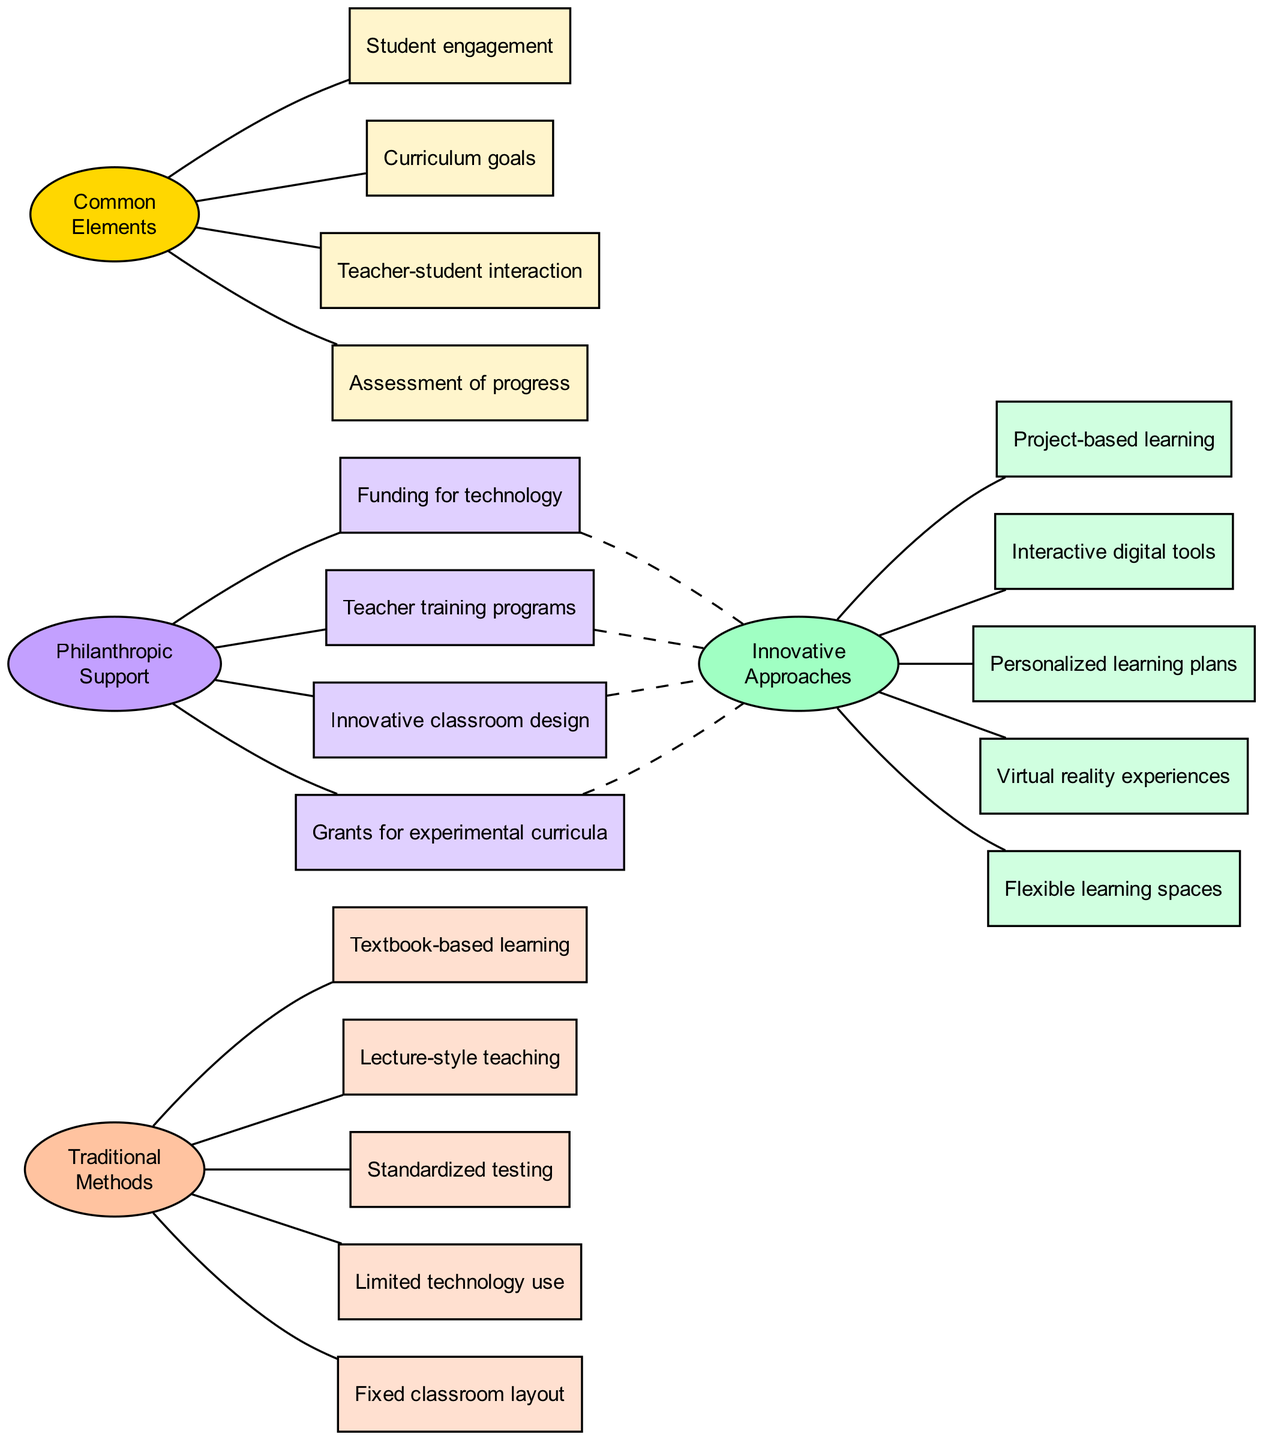What are the traditional methods listed in the diagram? The diagram includes a box for each of the traditional methods. All items listed in the traditional methods node are shown as separate boxes linked to it. The traditional methods include: Textbook-based learning, Lecture-style teaching, Standardized testing, Limited technology use, Fixed classroom layout.
Answer: Textbook-based learning, Lecture-style teaching, Standardized testing, Limited technology use, Fixed classroom layout How many innovative approaches are there in the diagram? Each innovative approach is represented by a separate box connected to the innovative approaches node. The innovative approaches listed are: Project-based learning, Interactive digital tools, Personalized learning plans, Virtual reality experiences, Flexible learning spaces. Counting these, we find there are five innovative approaches.
Answer: 5 What elements are common to both traditional and innovative methods? The diagram displays a central overlap node that connects both methods, and within this overlap, there are several common elements. The items listed include: Student engagement, Curriculum goals, Teacher-student interaction, Assessment of progress.
Answer: Student engagement, Curriculum goals, Teacher-student interaction, Assessment of progress Which philanthropic support is linked to innovative approaches? The philanthropic support node connects to several specific support areas that are represented as separate boxes. Each box is linked to the innovative node with a dashed line, indicating a supportive relationship between philanthropic funding and innovative approaches. The funding areas include: Funding for technology, Teacher training programs, Innovative classroom design, Grants for experimental curricula.
Answer: Funding for technology, Teacher training programs, Innovative classroom design, Grants for experimental curricula What is the purpose of the dashed edges in the diagram? Dashed edges in the diagram indicate a supportive or indirect relationship between philanthropic support and innovative approaches. This signifies that the philanthropic funding indirectly contributes to these approaches but does not represent a direct teaching method itself.
Answer: Supportive relationship How many total nodes are represented in the traditional methods? Each traditional method is represented by its own box, and there are five traditional methods listed under the traditional node. Additionally, there is a central traditional methods node that counts as one. Thus, the total is the five methods plus the one node, giving six nodes total.
Answer: 6 How does philanthropic support enhance innovative teaching methods? The diagram indicates that the philanthropic support creates a link to innovative approaches through the dashed edges, suggesting that these funding sources enable or improve innovative teaching practices. This support includes aspects like technology funding and teacher training, which enhance the teaching methods.
Answer: Enhances teaching practices Which educational element does not appear in the innovative approaches section? To find out what is missing, we compare the lists provided under traditional and innovative sections. The traditional methods include elements like Standardized testing and Fixed classroom layout which are not represented in the innovative approaches. The focus on interactive and flexible methods is absent.
Answer: Standardized testing, Fixed classroom layout 